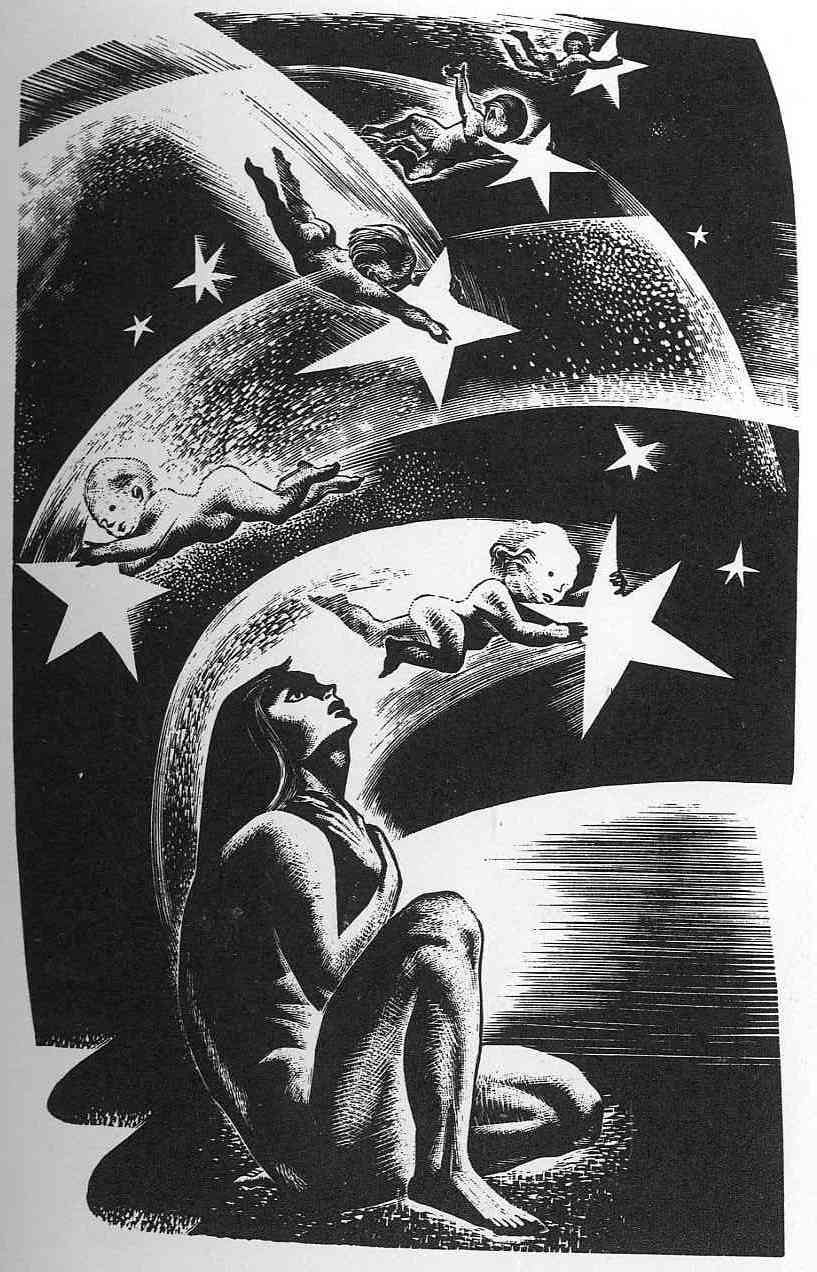Explain the visual content of the image in great detail. The image is a detailed black and white illustration with a dreamlike, fantasy theme. It depicts a woman sitting on a crescent moon that dominates the lower foreground, her posture reflective and contemplative, with her knees drawn close to her chest, and her head looking up, perhaps lost in thought or in admiration of her surroundings. She is surrounded by a swirling array of stars and celestial objects that seem almost in motion, enhancing the ethereal feel of the scene. Above and around her float three figures, possibly children or cherubs, who appear to be interacting playfully with the stars and space around them. The linework is intricate, utilizing heavy contrasts and detailed textures to create a vivid image that evokes a sense of wonder and mystery. 